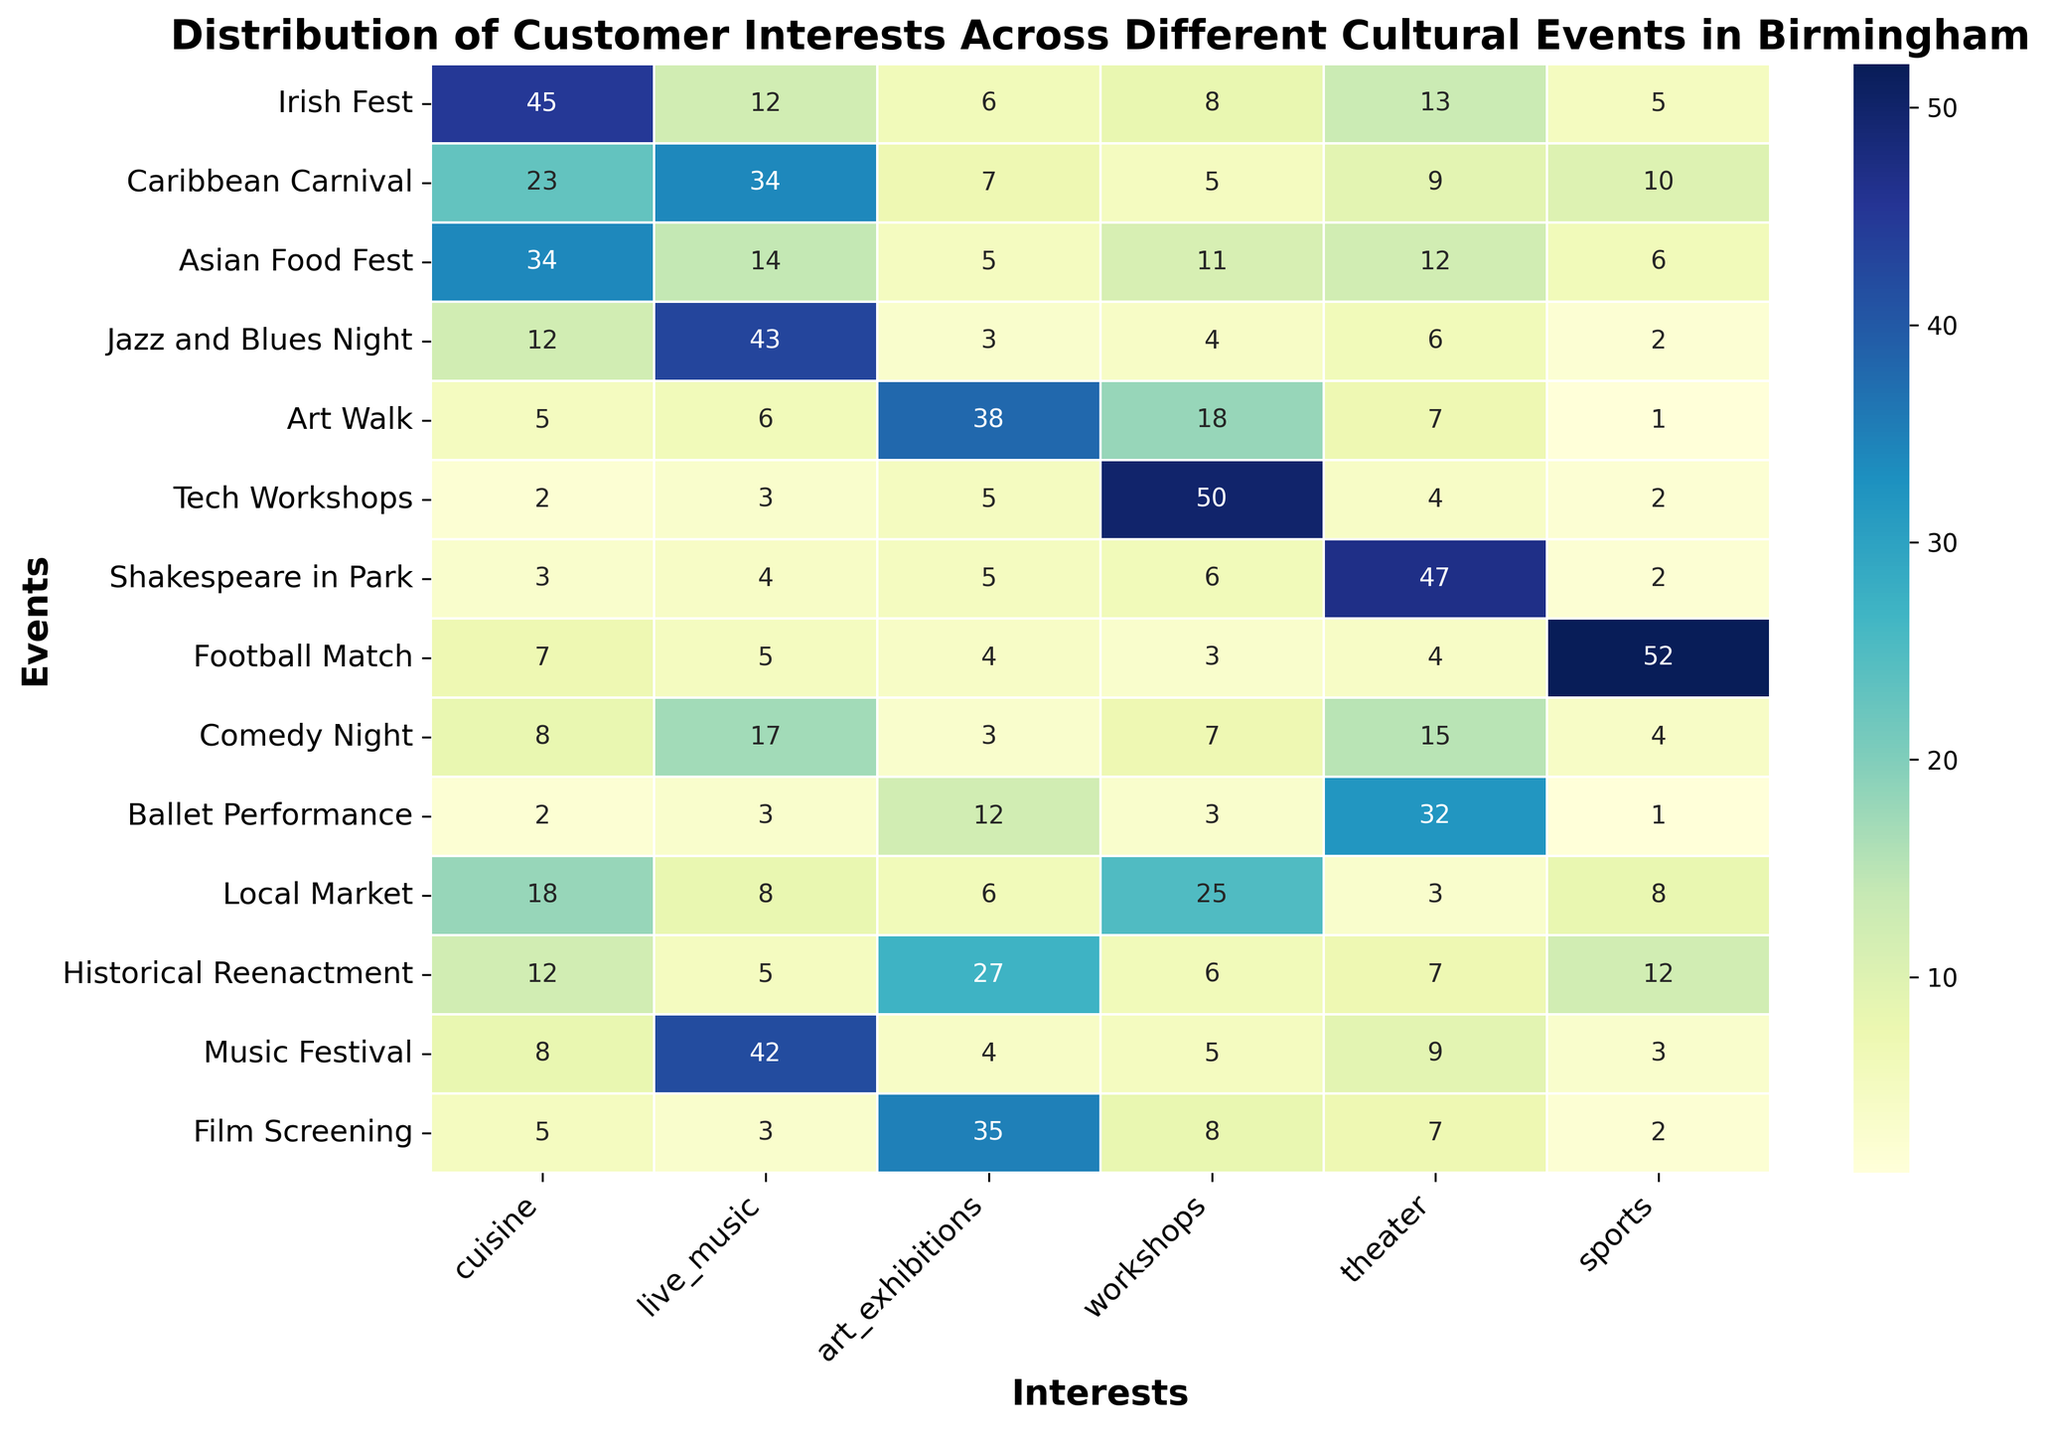Which event has the highest interest in tech workshops? The heatmap shows the intensity of interest in different categories for each event. The event with the highest value for tech workshops is the one with the darkest shade in the 'workshops' column. Here, Tech Workshops has the highest value of 50.
Answer: Tech Workshops Which event has the lowest interest in cuisine? To find the event with the lowest interest in cuisine, look for the smallest number in the cuisine column. The smallest number is 2, which corresponds to Ballet Performance and Tech Workshops.
Answer: Ballet Performance, Tech Workshops What is the sum of interests in live music and art exhibitions for the Music Festival? Look at the Music Festival row and add the values under the columns 'live_music' and 'art_exhibitions'. The values are 42 and 4, respectively, so the sum is 42 + 4 = 46.
Answer: 46 Which event has a higher interest in theater, Shakespeare in Park or Caribbean Carnival? Compare the values in the 'theater' column for Shakespeare in Park and Caribbean Carnival. Shakespeare in Park has 47 and Caribbean Carnival has 9. Thus, Shakespeare in Park has higher interest.
Answer: Shakespeare in Park What is the average interest in sports across all events? To calculate the average interest in sports, sum all the values in the 'sports' column and divide by the number of events. The sum is 5 + 10 + 6 + 2 + 1 + 2 + 2 + 52 + 4 + 1 + 8 + 12 + 3 = 108. There are 13 events, so the average is 108 / 13 ≈ 8.31.
Answer: ≈ 8.31 Which event has the largest difference in interest between cuisine and workshops? Calculate the absolute differences between the values for 'cuisine' and 'workshops' for each event, and identify the largest difference. The differences are: Irish Fest (37), Caribbean Carnival (18), Asian Food Fest (23), Jazz and Blues Night (8), Art Walk (13), Tech Workshops (48), Shakespeare in Park (3), Football Match (4), Comedy Night (1), Ballet Performance (9), Local Market (7), Historical Reenactment (6), Music Festival (3). The largest difference is 48 for Tech Workshops.
Answer: Tech Workshops Which event has a more even interest distribution across all categories? Look for the event where the values across all categories are more balanced/closely spaced. For example, Comedy Night has values 8, 17, 3, 7, 15, 4, which are fairly balanced compared to other events with more extreme differences.
Answer: Comedy Night Which event has similar levels of interest in art exhibitions and live music? Look for the event where the values for 'art_exhibitions' and 'live_music' are close to each other. For example, Art Walk has values 38 for art exhibitions and 6 for live music, which are not close. In contrast, Historical Reenactment has values 27 for art exhibitions and 5 for live music, which are closer.
Answer: Historical Reenactment 